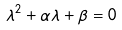<formula> <loc_0><loc_0><loc_500><loc_500>\lambda ^ { 2 } + \alpha \lambda + \beta = 0</formula> 